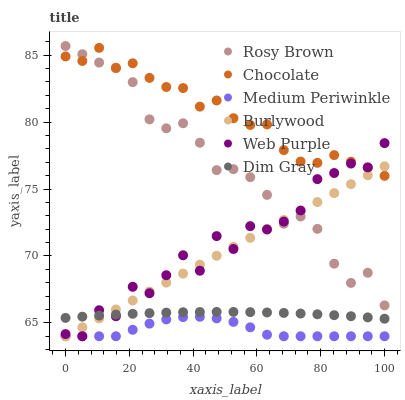Does Medium Periwinkle have the minimum area under the curve?
Answer yes or no. Yes. Does Chocolate have the maximum area under the curve?
Answer yes or no. Yes. Does Burlywood have the minimum area under the curve?
Answer yes or no. No. Does Burlywood have the maximum area under the curve?
Answer yes or no. No. Is Burlywood the smoothest?
Answer yes or no. Yes. Is Web Purple the roughest?
Answer yes or no. Yes. Is Rosy Brown the smoothest?
Answer yes or no. No. Is Rosy Brown the roughest?
Answer yes or no. No. Does Burlywood have the lowest value?
Answer yes or no. Yes. Does Rosy Brown have the lowest value?
Answer yes or no. No. Does Rosy Brown have the highest value?
Answer yes or no. Yes. Does Burlywood have the highest value?
Answer yes or no. No. Is Medium Periwinkle less than Rosy Brown?
Answer yes or no. Yes. Is Dim Gray greater than Medium Periwinkle?
Answer yes or no. Yes. Does Chocolate intersect Rosy Brown?
Answer yes or no. Yes. Is Chocolate less than Rosy Brown?
Answer yes or no. No. Is Chocolate greater than Rosy Brown?
Answer yes or no. No. Does Medium Periwinkle intersect Rosy Brown?
Answer yes or no. No. 